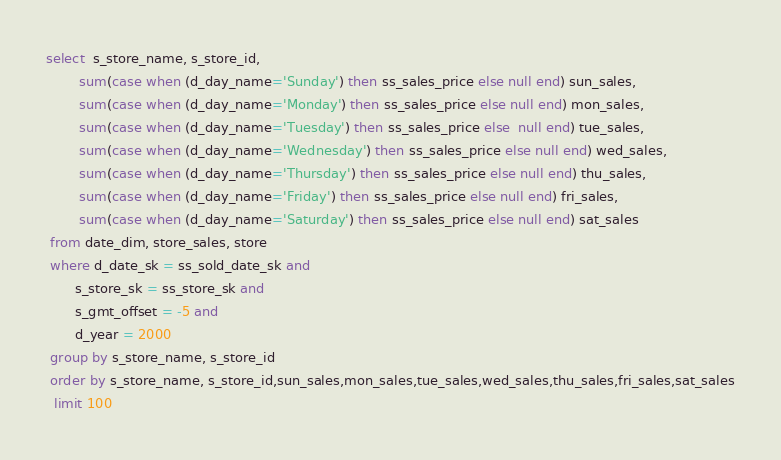<code> <loc_0><loc_0><loc_500><loc_500><_SQL_>select  s_store_name, s_store_id,
        sum(case when (d_day_name='Sunday') then ss_sales_price else null end) sun_sales,
        sum(case when (d_day_name='Monday') then ss_sales_price else null end) mon_sales,
        sum(case when (d_day_name='Tuesday') then ss_sales_price else  null end) tue_sales,
        sum(case when (d_day_name='Wednesday') then ss_sales_price else null end) wed_sales,
        sum(case when (d_day_name='Thursday') then ss_sales_price else null end) thu_sales,
        sum(case when (d_day_name='Friday') then ss_sales_price else null end) fri_sales,
        sum(case when (d_day_name='Saturday') then ss_sales_price else null end) sat_sales
 from date_dim, store_sales, store
 where d_date_sk = ss_sold_date_sk and
       s_store_sk = ss_store_sk and
       s_gmt_offset = -5 and
       d_year = 2000 
 group by s_store_name, s_store_id
 order by s_store_name, s_store_id,sun_sales,mon_sales,tue_sales,wed_sales,thu_sales,fri_sales,sat_sales
  limit 100
</code> 